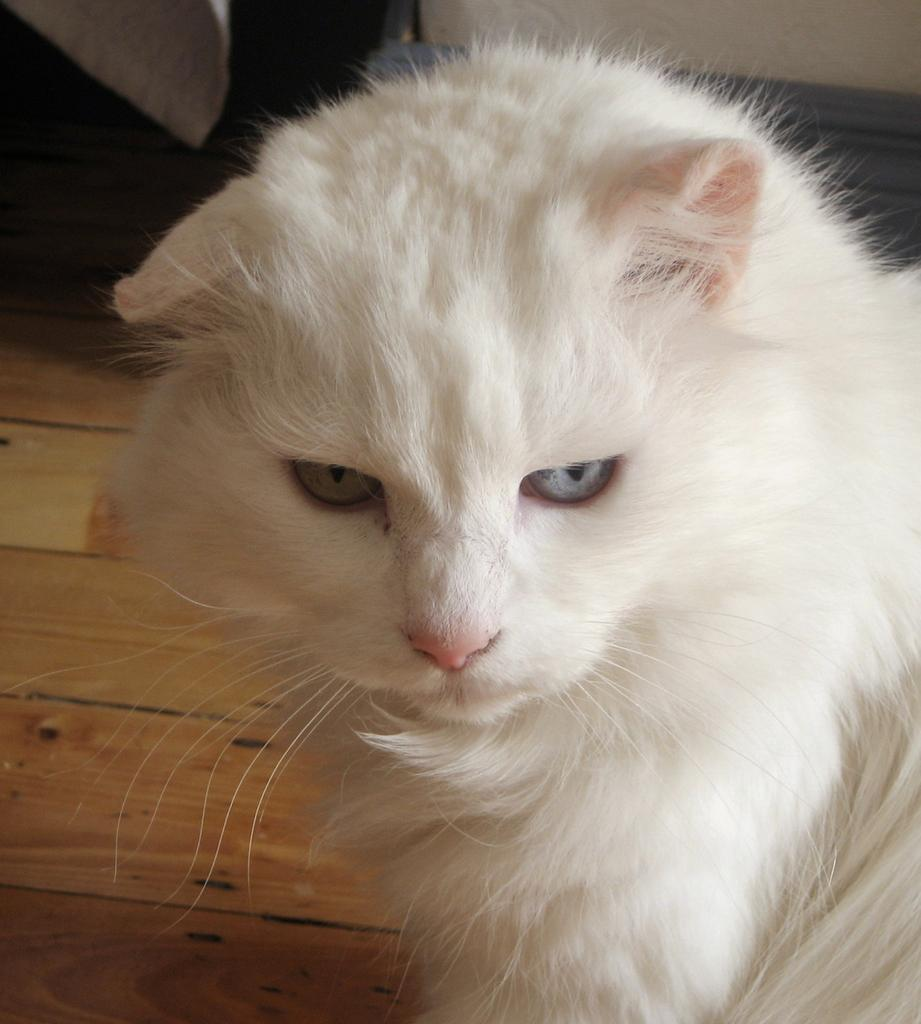What is the main subject in the foreground of the picture? There is a cat in the foreground of the picture. What is the cat sitting on? The cat is sitting on wooden planks. Can you describe the background of the picture? There are objects visible in the background of the picture. How does the cat use its ear to communicate with the objects in the background? The cat does not use its ear to communicate with the objects in the background, as there is no indication of any interaction or communication between the cat and the objects in the image. 